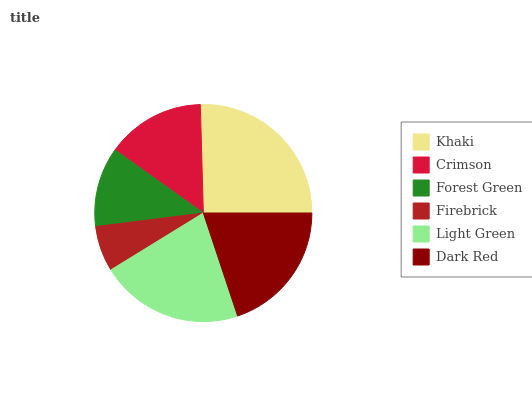Is Firebrick the minimum?
Answer yes or no. Yes. Is Khaki the maximum?
Answer yes or no. Yes. Is Crimson the minimum?
Answer yes or no. No. Is Crimson the maximum?
Answer yes or no. No. Is Khaki greater than Crimson?
Answer yes or no. Yes. Is Crimson less than Khaki?
Answer yes or no. Yes. Is Crimson greater than Khaki?
Answer yes or no. No. Is Khaki less than Crimson?
Answer yes or no. No. Is Dark Red the high median?
Answer yes or no. Yes. Is Crimson the low median?
Answer yes or no. Yes. Is Light Green the high median?
Answer yes or no. No. Is Light Green the low median?
Answer yes or no. No. 